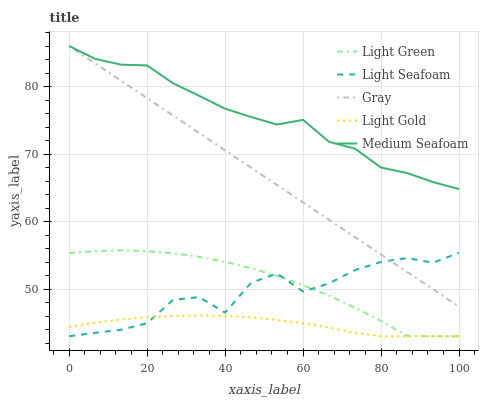Does Light Gold have the minimum area under the curve?
Answer yes or no. Yes. Does Medium Seafoam have the maximum area under the curve?
Answer yes or no. Yes. Does Light Seafoam have the minimum area under the curve?
Answer yes or no. No. Does Light Seafoam have the maximum area under the curve?
Answer yes or no. No. Is Gray the smoothest?
Answer yes or no. Yes. Is Light Seafoam the roughest?
Answer yes or no. Yes. Is Light Gold the smoothest?
Answer yes or no. No. Is Light Gold the roughest?
Answer yes or no. No. Does Light Seafoam have the lowest value?
Answer yes or no. Yes. Does Medium Seafoam have the lowest value?
Answer yes or no. No. Does Medium Seafoam have the highest value?
Answer yes or no. Yes. Does Light Seafoam have the highest value?
Answer yes or no. No. Is Light Green less than Gray?
Answer yes or no. Yes. Is Medium Seafoam greater than Light Green?
Answer yes or no. Yes. Does Light Seafoam intersect Gray?
Answer yes or no. Yes. Is Light Seafoam less than Gray?
Answer yes or no. No. Is Light Seafoam greater than Gray?
Answer yes or no. No. Does Light Green intersect Gray?
Answer yes or no. No. 